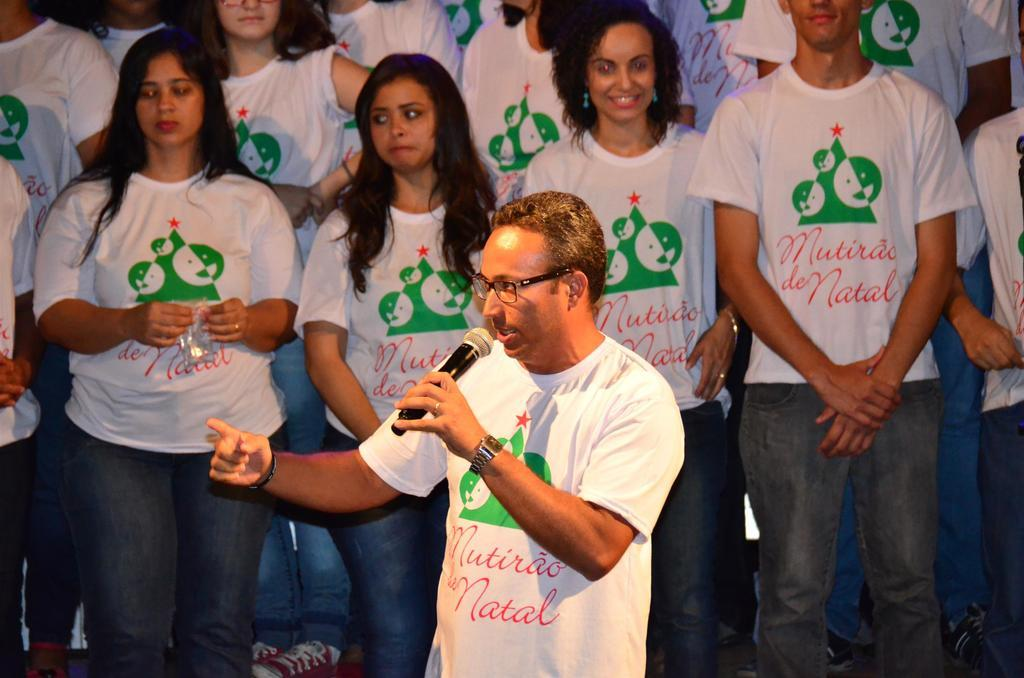What is happening in the image? There are people standing in the image. What can be observed about the clothing of some of the people? Some of the people are wearing white, red, and green t-shirts. Can you describe the person standing in front? One person is standing in front and holding a mic. What type of toy can be seen in the hands of the person wearing a red t-shirt? There is no toy visible in the image, and no person is specifically mentioned as wearing a red t-shirt. 